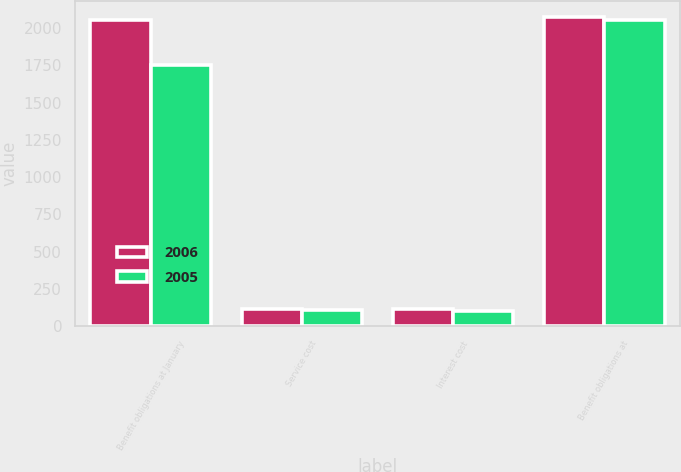Convert chart. <chart><loc_0><loc_0><loc_500><loc_500><stacked_bar_chart><ecel><fcel>Benefit obligations at January<fcel>Service cost<fcel>Interest cost<fcel>Benefit obligations at<nl><fcel>2006<fcel>2055<fcel>117<fcel>113<fcel>2077<nl><fcel>2005<fcel>1750<fcel>109<fcel>104<fcel>2055<nl></chart> 